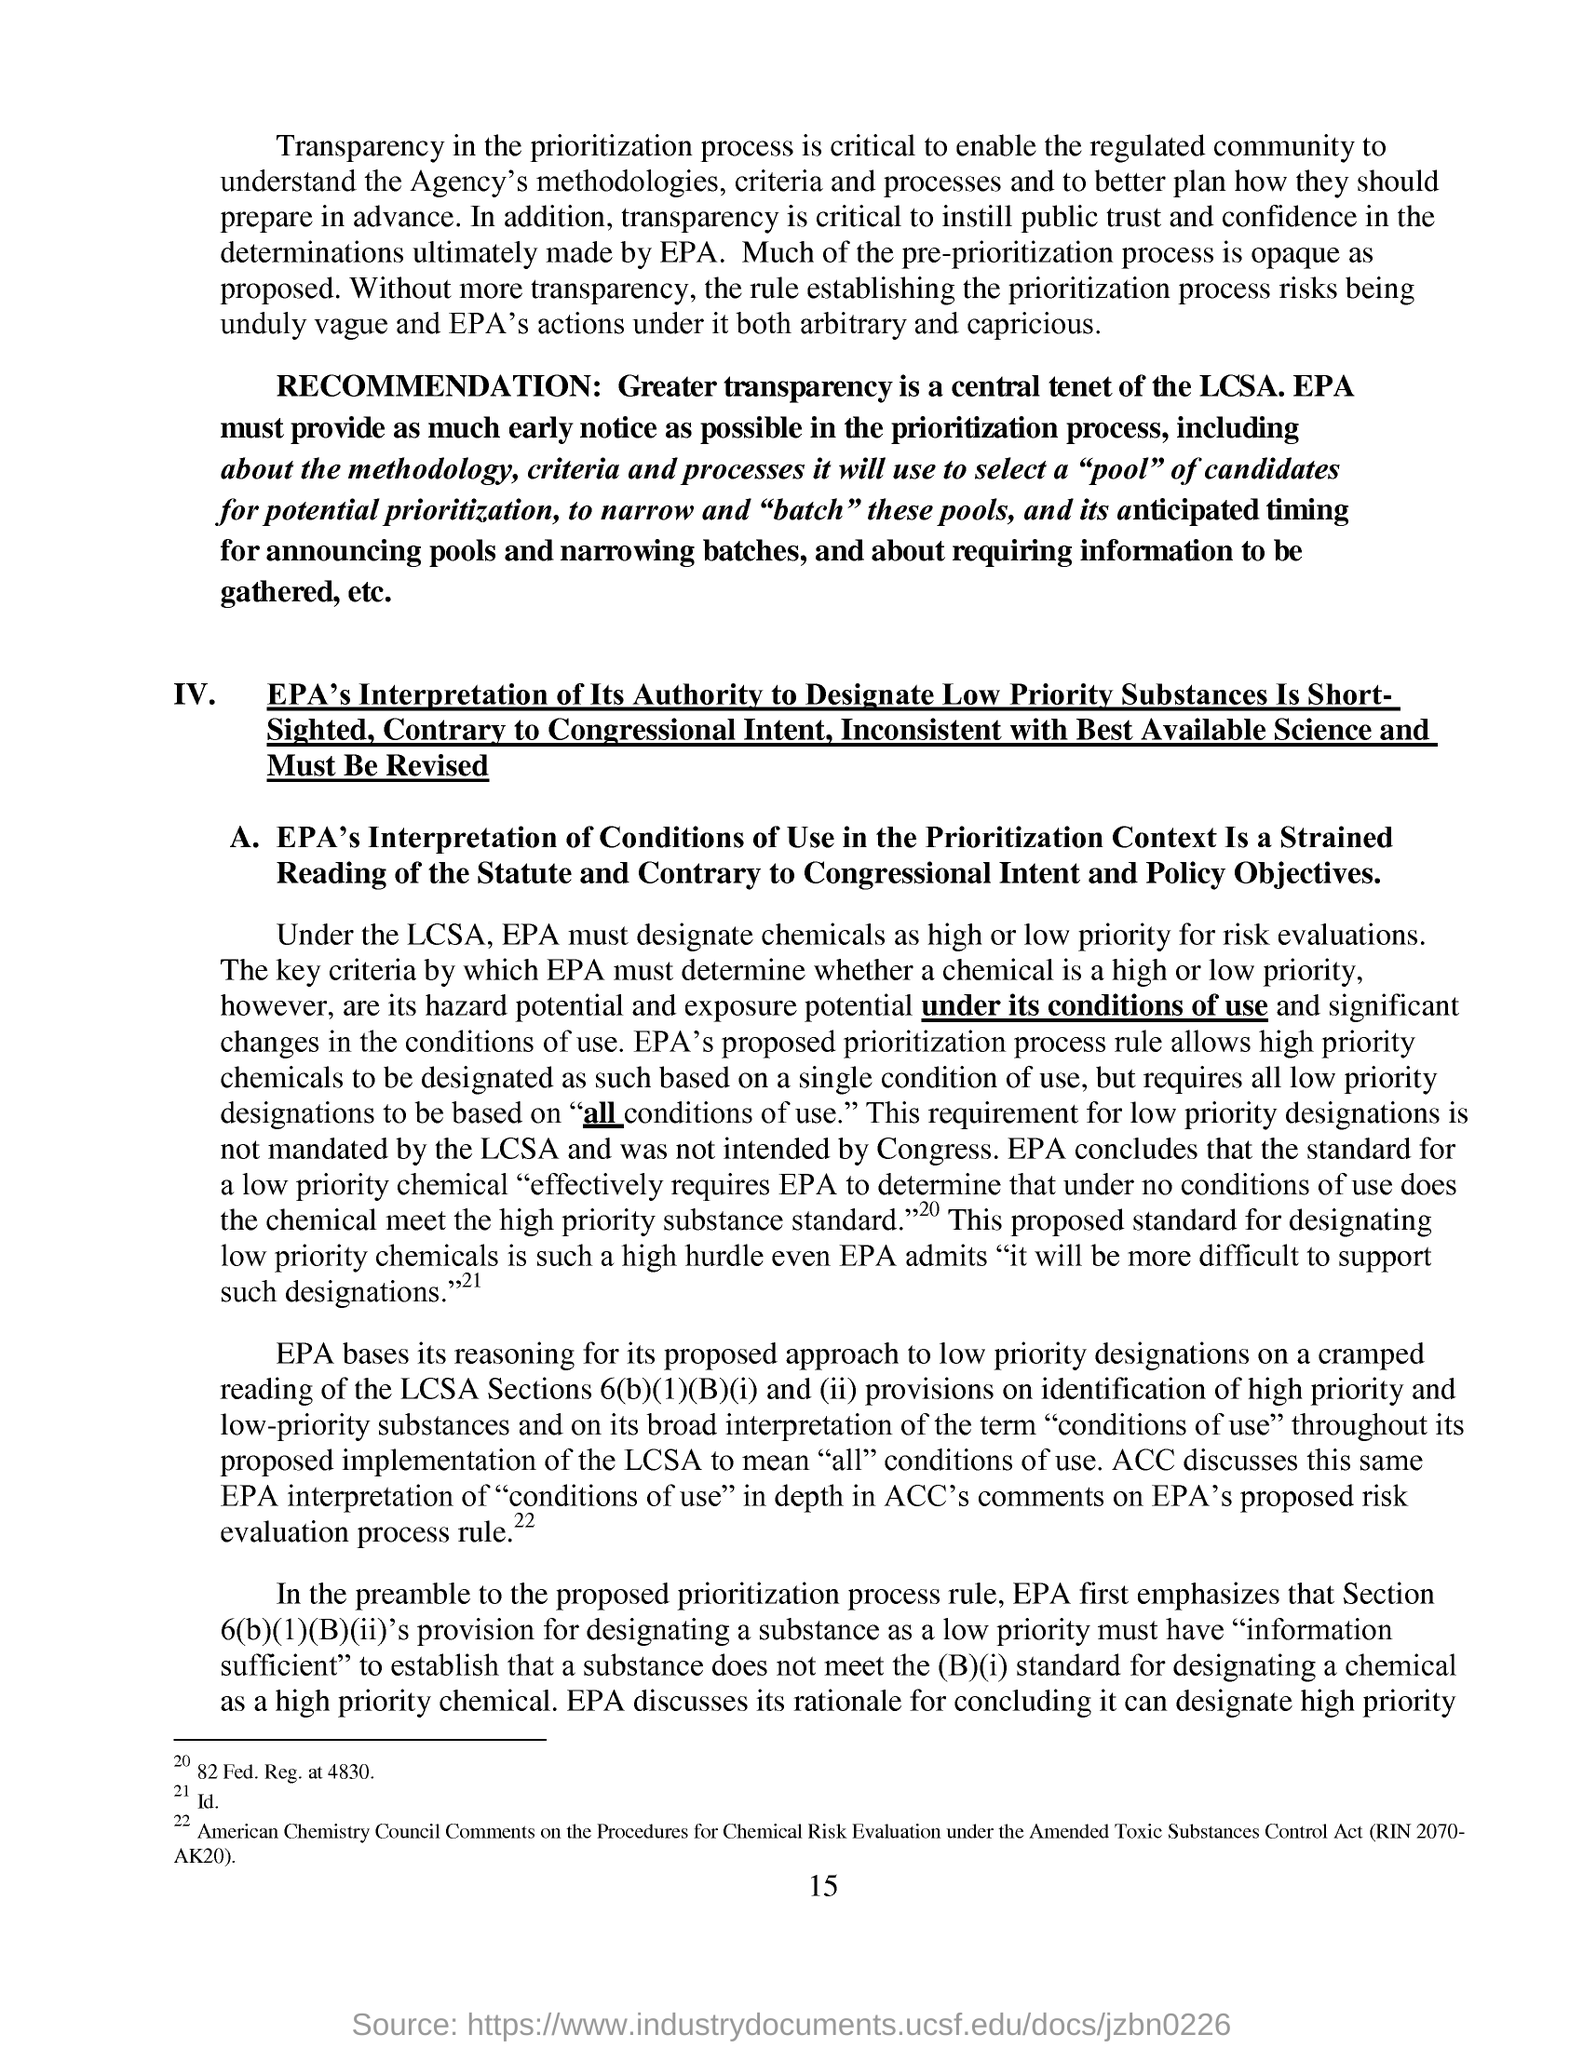What is the central tenet of LCSA as per RECOMMENDATION?
Ensure brevity in your answer.  Greater transparency. What is the page number given at the footer?
Your answer should be compact. 15. 